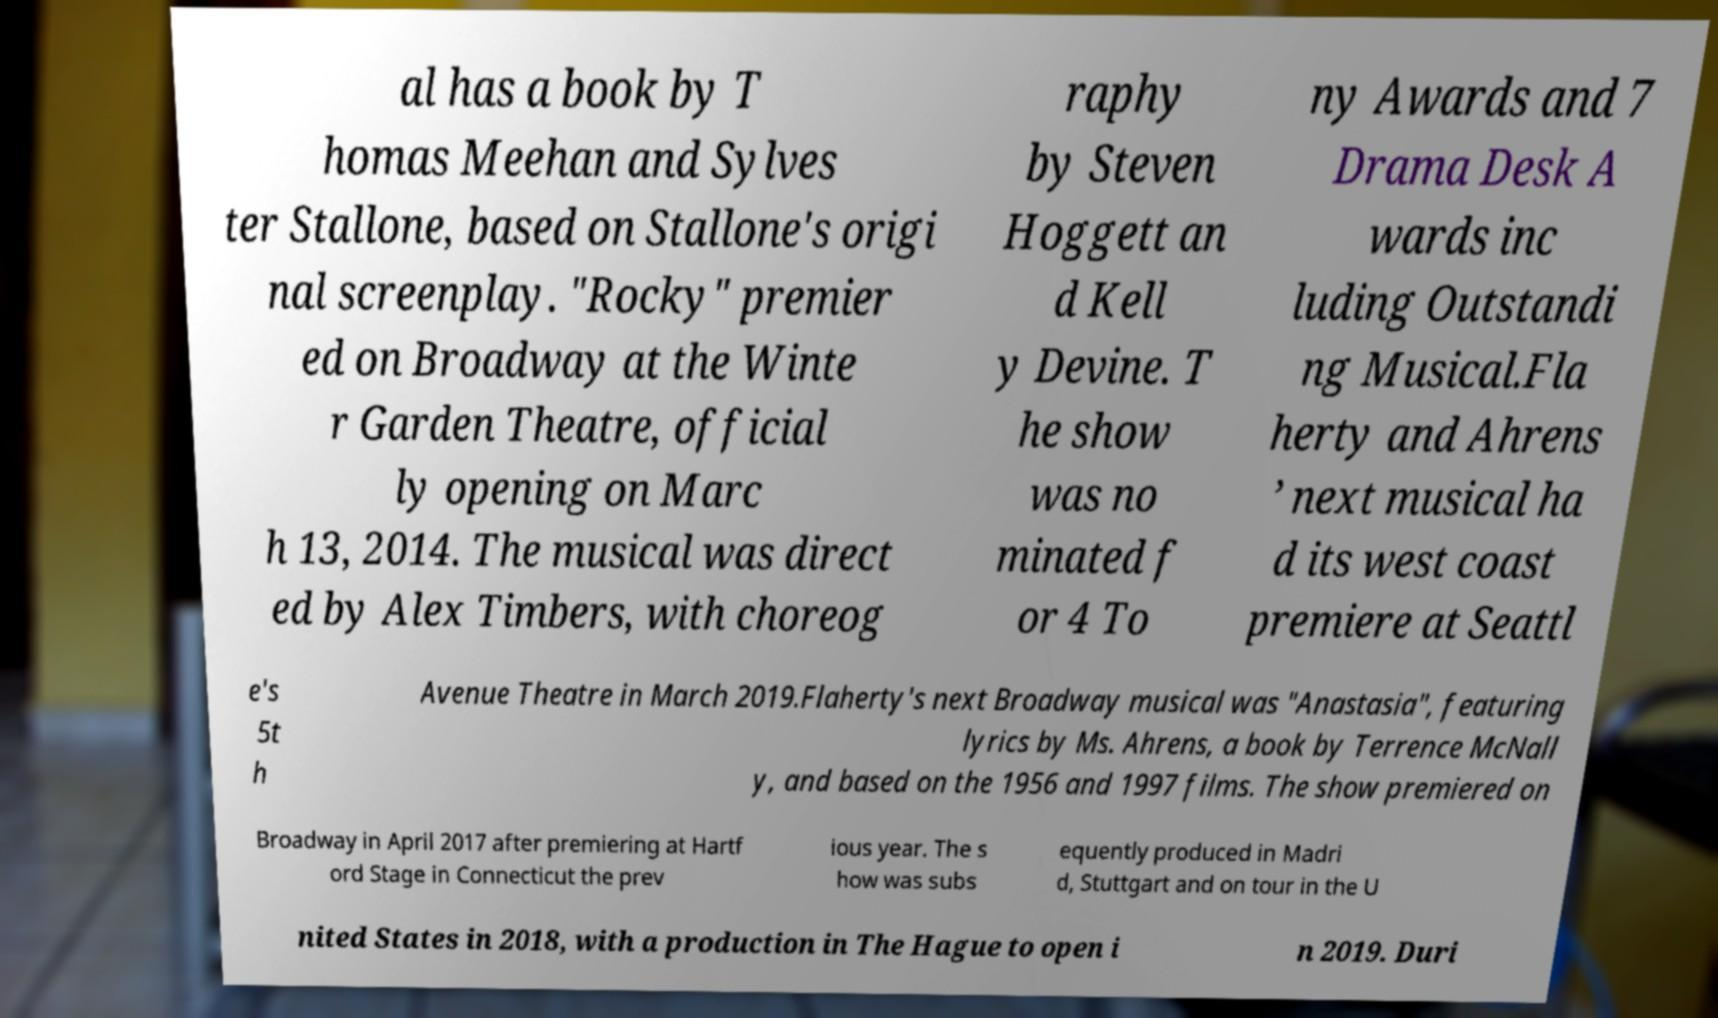Please read and relay the text visible in this image. What does it say? al has a book by T homas Meehan and Sylves ter Stallone, based on Stallone's origi nal screenplay. "Rocky" premier ed on Broadway at the Winte r Garden Theatre, official ly opening on Marc h 13, 2014. The musical was direct ed by Alex Timbers, with choreog raphy by Steven Hoggett an d Kell y Devine. T he show was no minated f or 4 To ny Awards and 7 Drama Desk A wards inc luding Outstandi ng Musical.Fla herty and Ahrens ’ next musical ha d its west coast premiere at Seattl e's 5t h Avenue Theatre in March 2019.Flaherty's next Broadway musical was "Anastasia", featuring lyrics by Ms. Ahrens, a book by Terrence McNall y, and based on the 1956 and 1997 films. The show premiered on Broadway in April 2017 after premiering at Hartf ord Stage in Connecticut the prev ious year. The s how was subs equently produced in Madri d, Stuttgart and on tour in the U nited States in 2018, with a production in The Hague to open i n 2019. Duri 